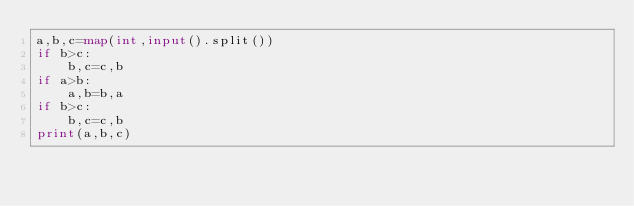Convert code to text. <code><loc_0><loc_0><loc_500><loc_500><_Python_>a,b,c=map(int,input().split())
if b>c:
    b,c=c,b
if a>b:
    a,b=b,a
if b>c:
    b,c=c,b
print(a,b,c)
</code> 